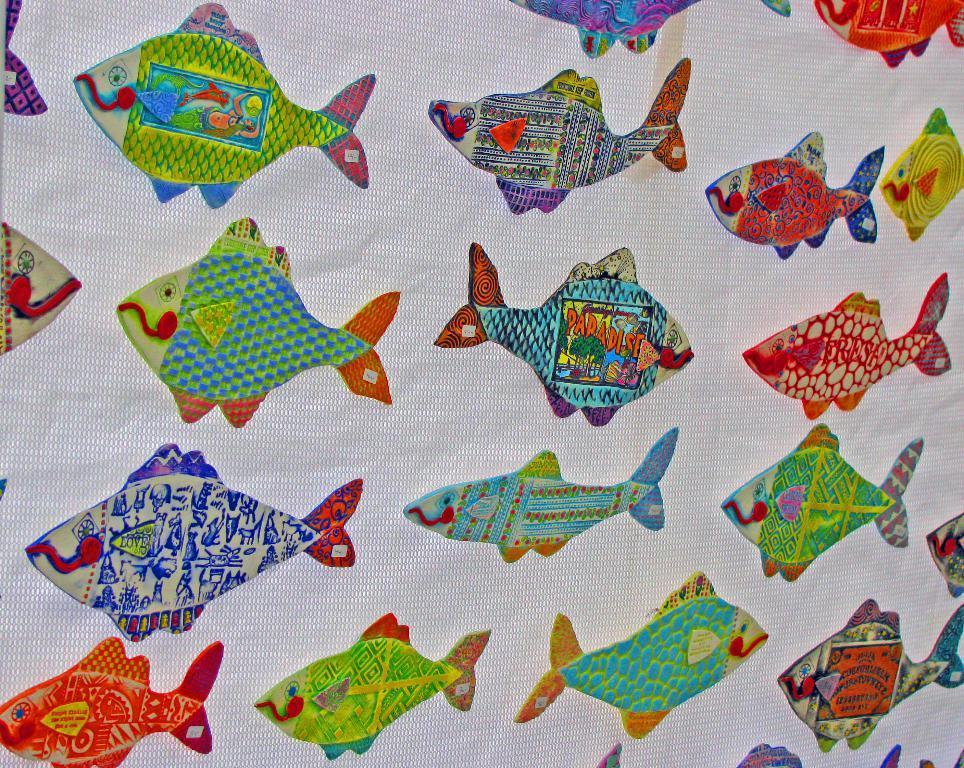Describe this image in one or two sentences. We can see thread craft of fishes on white cloth. 